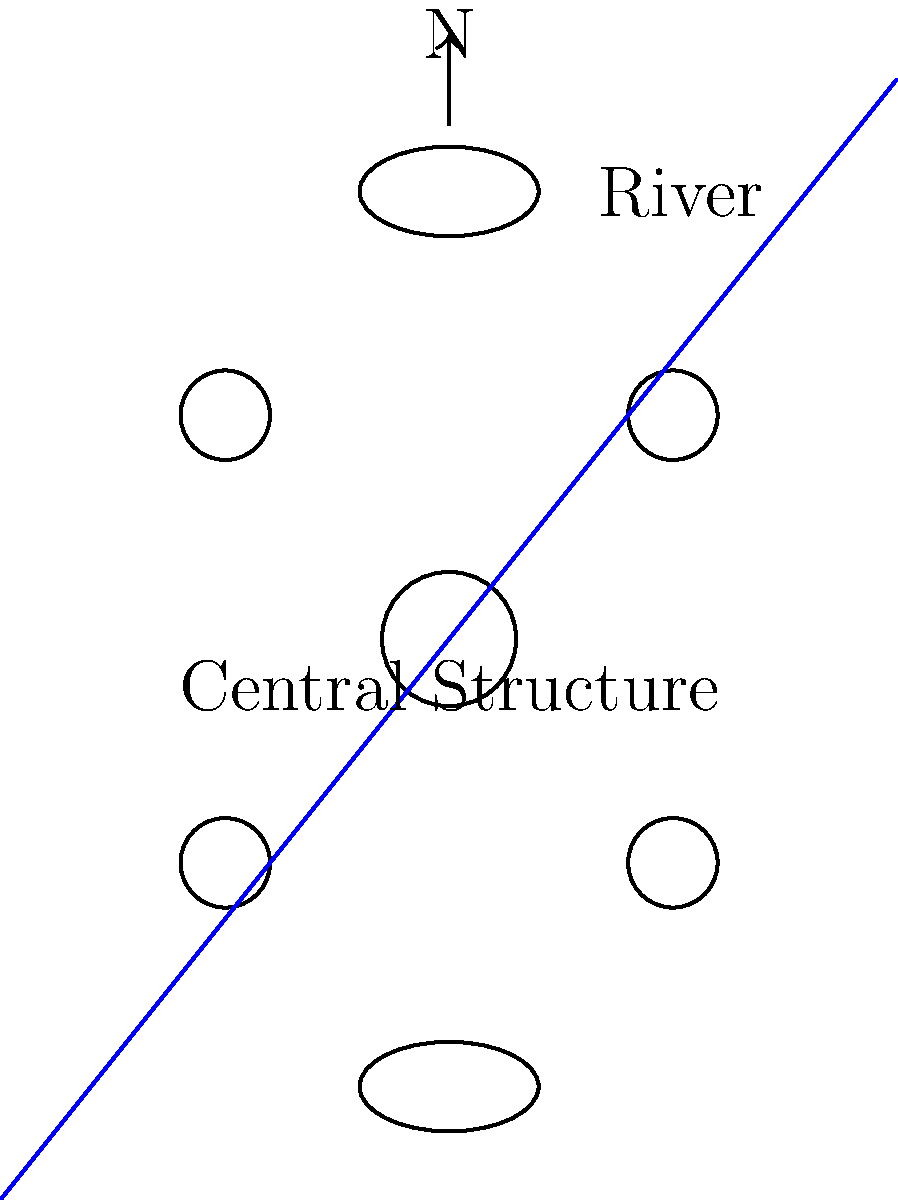Based on the layout of this ancient settlement site, what can be inferred about the social structure and resource utilization of the society that inhabited it? To interpret the layout of this ancient settlement site, we need to analyze its components step-by-step:

1. Central Structure: There's a larger circular structure at the center, which suggests:
   a) A hierarchical society with a central authority or gathering place
   b) Possible religious or administrative importance

2. Surrounding Structures: Four smaller circular structures surround the central one in a symmetrical pattern, indicating:
   a) Planned layout, not random settlement
   b) Possible division of society into distinct groups or families

3. Elongated Structures: Two elliptical structures are positioned at the top and bottom of the settlement, which could represent:
   a) Specialized buildings for storage, communal activities, or specific crafts
   b) Possible differentiation in building techniques or purposes

4. River Proximity: A river runs diagonally through the settlement, suggesting:
   a) Intentional positioning near a water source for survival and resource access
   b) Possible use of the river for transportation or trade

5. Orientation: The presence of a north arrow indicates intentional orientation, possibly related to:
   a) Astronomical observations or seasonal changes
   b) Cultural or religious significance of cardinal directions

6. Symmetry and Planning: The overall symmetrical layout implies:
   a) A well-organized society with urban planning capabilities
   b) Possible symbolic or cosmological significance in the arrangement

Given these observations, we can infer that this society likely had:
1. A hierarchical structure with centralized leadership or religious authority
2. Planned urban development and architectural knowledge
3. Specialized roles or divisions within the community
4. Intentional resource management, particularly regarding water access
5. Possible astronomical or directional significance in their cultural practices
6. A level of social complexity that allowed for organized labor and construction
Answer: Hierarchical, planned society with centralized authority, specialized roles, and intentional resource management, particularly focused on water access and possible astronomical significance. 